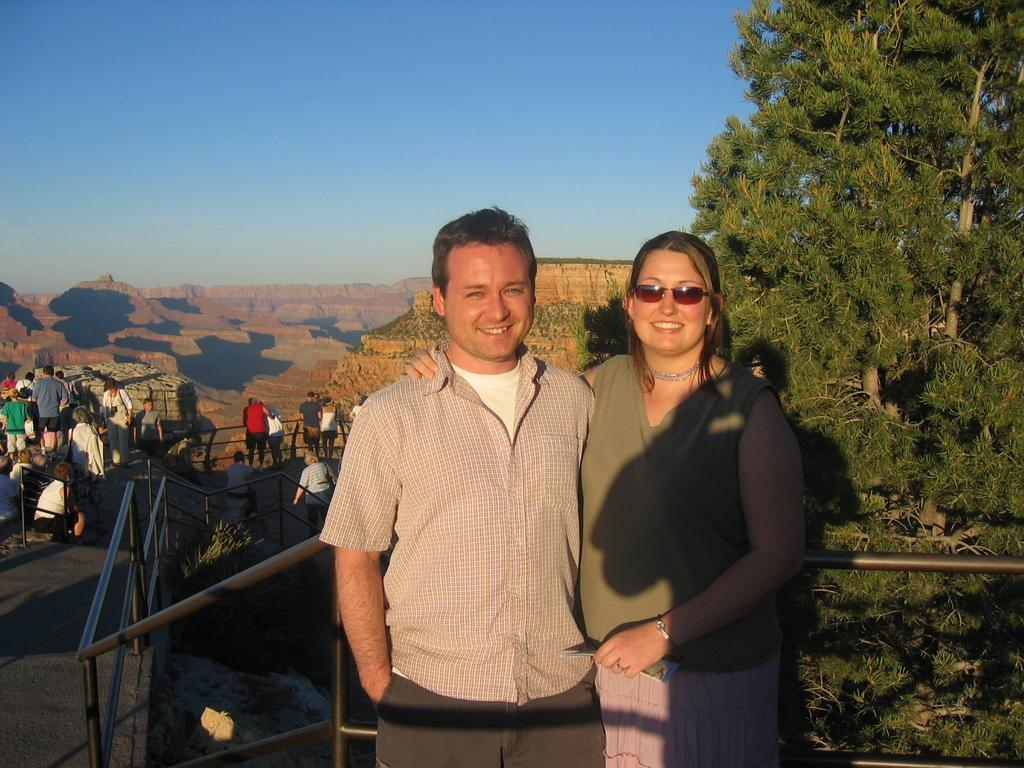How many people are in the image? There are two people standing in the center of the image. What can be seen in the image besides the people? There is railing, mountains, trees, and people in the background of the image. What is the landscape like in the background of the image? The background of the image features mountains and trees. Are there any other people visible in the image? Yes, there are people in the background of the image. What shape is the volleyball in the image? There is no volleyball present in the image. Can you describe the elbow of the person in the image? There is no specific mention of an elbow in the image, and we cannot make assumptions about body parts. 